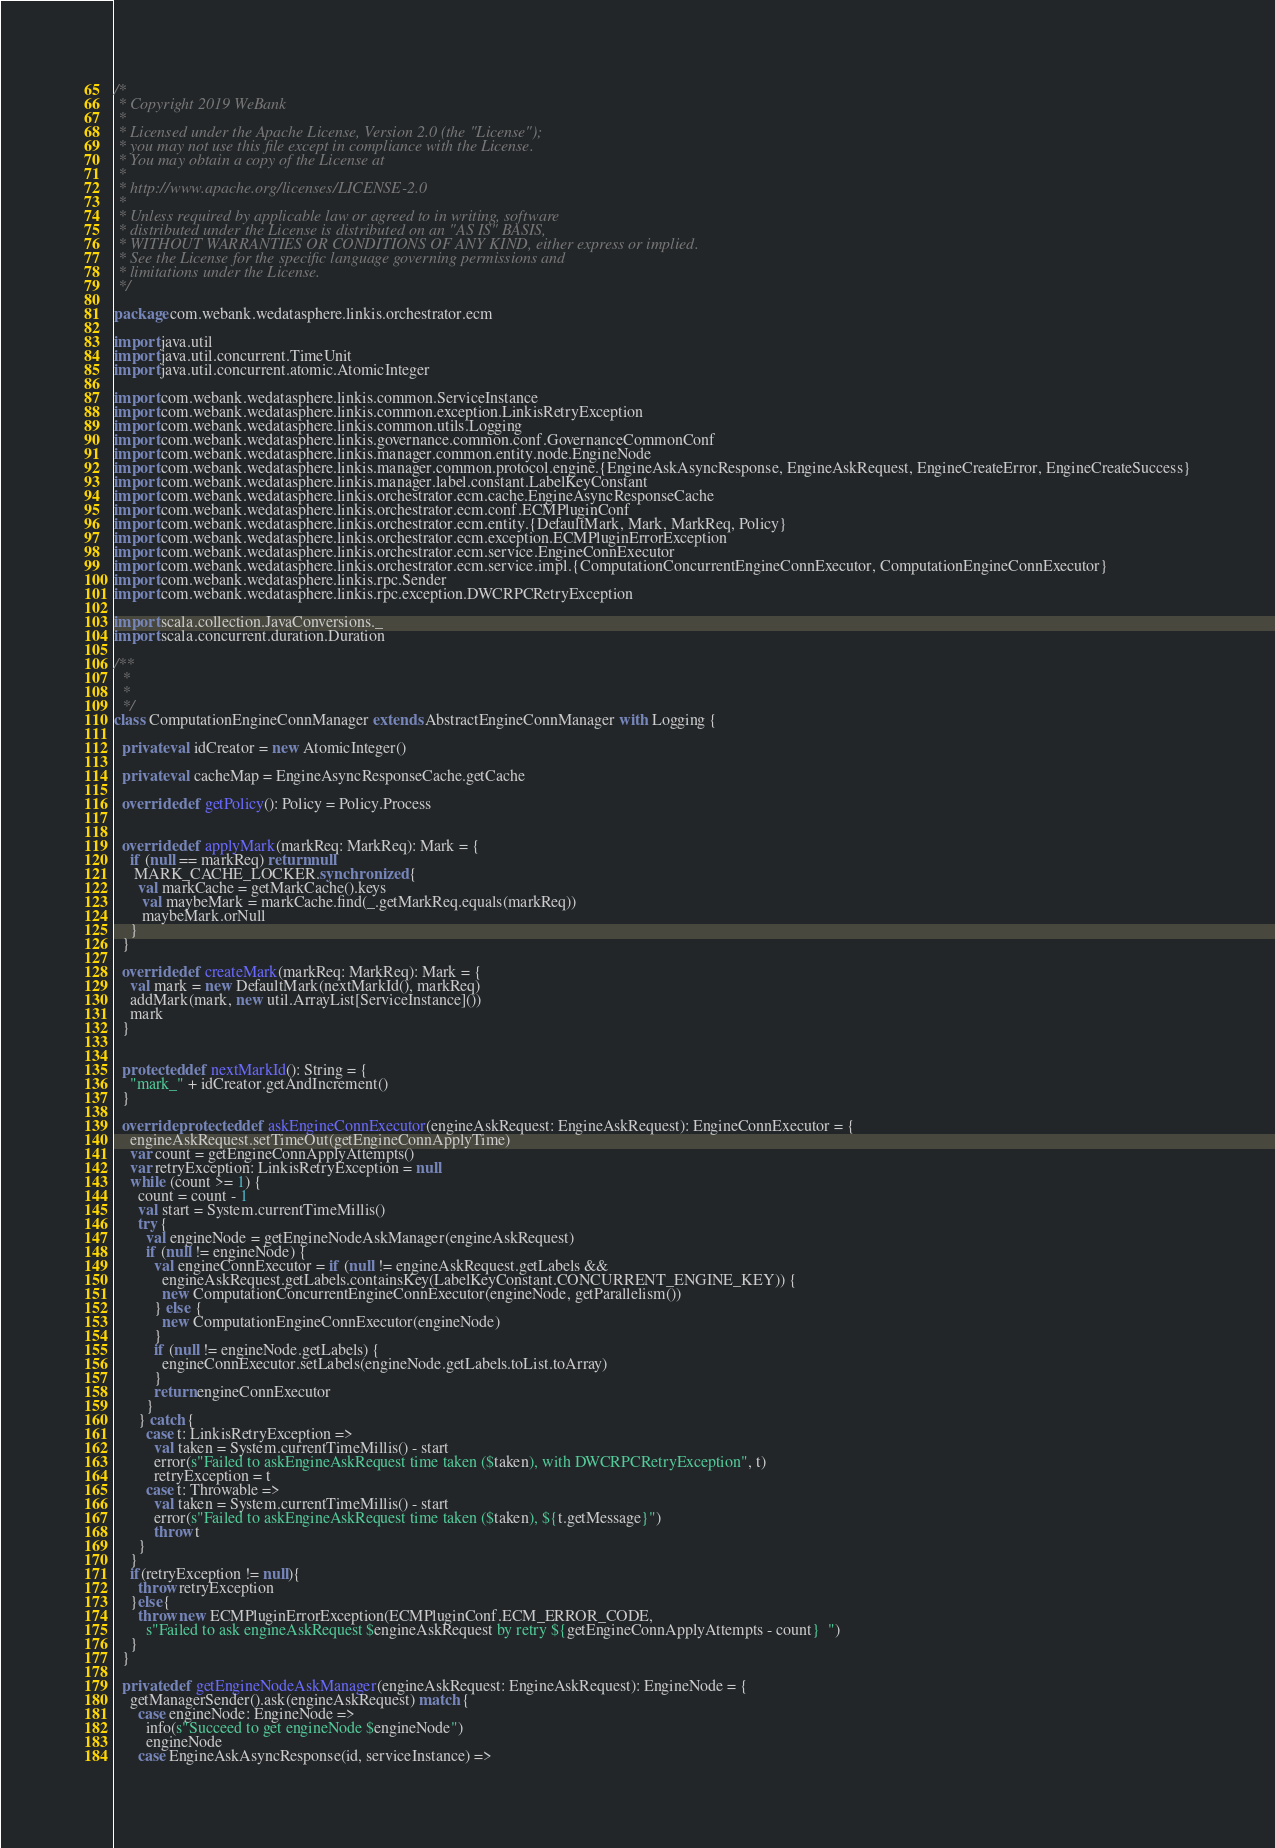<code> <loc_0><loc_0><loc_500><loc_500><_Scala_>/*
 * Copyright 2019 WeBank
 *
 * Licensed under the Apache License, Version 2.0 (the "License");
 * you may not use this file except in compliance with the License.
 * You may obtain a copy of the License at
 *
 * http://www.apache.org/licenses/LICENSE-2.0
 *
 * Unless required by applicable law or agreed to in writing, software
 * distributed under the License is distributed on an "AS IS" BASIS,
 * WITHOUT WARRANTIES OR CONDITIONS OF ANY KIND, either express or implied.
 * See the License for the specific language governing permissions and
 * limitations under the License.
 */

package com.webank.wedatasphere.linkis.orchestrator.ecm

import java.util
import java.util.concurrent.TimeUnit
import java.util.concurrent.atomic.AtomicInteger

import com.webank.wedatasphere.linkis.common.ServiceInstance
import com.webank.wedatasphere.linkis.common.exception.LinkisRetryException
import com.webank.wedatasphere.linkis.common.utils.Logging
import com.webank.wedatasphere.linkis.governance.common.conf.GovernanceCommonConf
import com.webank.wedatasphere.linkis.manager.common.entity.node.EngineNode
import com.webank.wedatasphere.linkis.manager.common.protocol.engine.{EngineAskAsyncResponse, EngineAskRequest, EngineCreateError, EngineCreateSuccess}
import com.webank.wedatasphere.linkis.manager.label.constant.LabelKeyConstant
import com.webank.wedatasphere.linkis.orchestrator.ecm.cache.EngineAsyncResponseCache
import com.webank.wedatasphere.linkis.orchestrator.ecm.conf.ECMPluginConf
import com.webank.wedatasphere.linkis.orchestrator.ecm.entity.{DefaultMark, Mark, MarkReq, Policy}
import com.webank.wedatasphere.linkis.orchestrator.ecm.exception.ECMPluginErrorException
import com.webank.wedatasphere.linkis.orchestrator.ecm.service.EngineConnExecutor
import com.webank.wedatasphere.linkis.orchestrator.ecm.service.impl.{ComputationConcurrentEngineConnExecutor, ComputationEngineConnExecutor}
import com.webank.wedatasphere.linkis.rpc.Sender
import com.webank.wedatasphere.linkis.rpc.exception.DWCRPCRetryException

import scala.collection.JavaConversions._
import scala.concurrent.duration.Duration

/**
  *
  *
  */
class ComputationEngineConnManager extends AbstractEngineConnManager with Logging {

  private val idCreator = new AtomicInteger()

  private val cacheMap = EngineAsyncResponseCache.getCache

  override def getPolicy(): Policy = Policy.Process


  override def applyMark(markReq: MarkReq): Mark = {
    if (null == markReq) return null
     MARK_CACHE_LOCKER.synchronized {
      val markCache = getMarkCache().keys
       val maybeMark = markCache.find(_.getMarkReq.equals(markReq))
       maybeMark.orNull
    }
  }

  override def createMark(markReq: MarkReq): Mark = {
    val mark = new DefaultMark(nextMarkId(), markReq)
    addMark(mark, new util.ArrayList[ServiceInstance]())
    mark
  }


  protected def nextMarkId(): String = {
    "mark_" + idCreator.getAndIncrement()
  }

  override protected def askEngineConnExecutor(engineAskRequest: EngineAskRequest): EngineConnExecutor = {
    engineAskRequest.setTimeOut(getEngineConnApplyTime)
    var count = getEngineConnApplyAttempts()
    var retryException: LinkisRetryException = null
    while (count >= 1) {
      count = count - 1
      val start = System.currentTimeMillis()
      try {
        val engineNode = getEngineNodeAskManager(engineAskRequest)
        if (null != engineNode) {
          val engineConnExecutor = if (null != engineAskRequest.getLabels &&
            engineAskRequest.getLabels.containsKey(LabelKeyConstant.CONCURRENT_ENGINE_KEY)) {
            new ComputationConcurrentEngineConnExecutor(engineNode, getParallelism())
          } else {
            new ComputationEngineConnExecutor(engineNode)
          }
          if (null != engineNode.getLabels) {
            engineConnExecutor.setLabels(engineNode.getLabels.toList.toArray)
          }
          return engineConnExecutor
        }
      } catch {
        case t: LinkisRetryException =>
          val taken = System.currentTimeMillis() - start
          error(s"Failed to askEngineAskRequest time taken ($taken), with DWCRPCRetryException", t)
          retryException = t
        case t: Throwable =>
          val taken = System.currentTimeMillis() - start
          error(s"Failed to askEngineAskRequest time taken ($taken), ${t.getMessage}")
          throw t
      }
    }
    if(retryException != null){
      throw retryException
    }else{
      throw new ECMPluginErrorException(ECMPluginConf.ECM_ERROR_CODE,
        s"Failed to ask engineAskRequest $engineAskRequest by retry ${getEngineConnApplyAttempts - count}  ")
    }
  }

  private def getEngineNodeAskManager(engineAskRequest: EngineAskRequest): EngineNode = {
    getManagerSender().ask(engineAskRequest) match {
      case engineNode: EngineNode =>
        info(s"Succeed to get engineNode $engineNode")
        engineNode
      case EngineAskAsyncResponse(id, serviceInstance) =></code> 